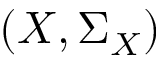Convert formula to latex. <formula><loc_0><loc_0><loc_500><loc_500>\left ( X , \Sigma _ { X } \right )</formula> 